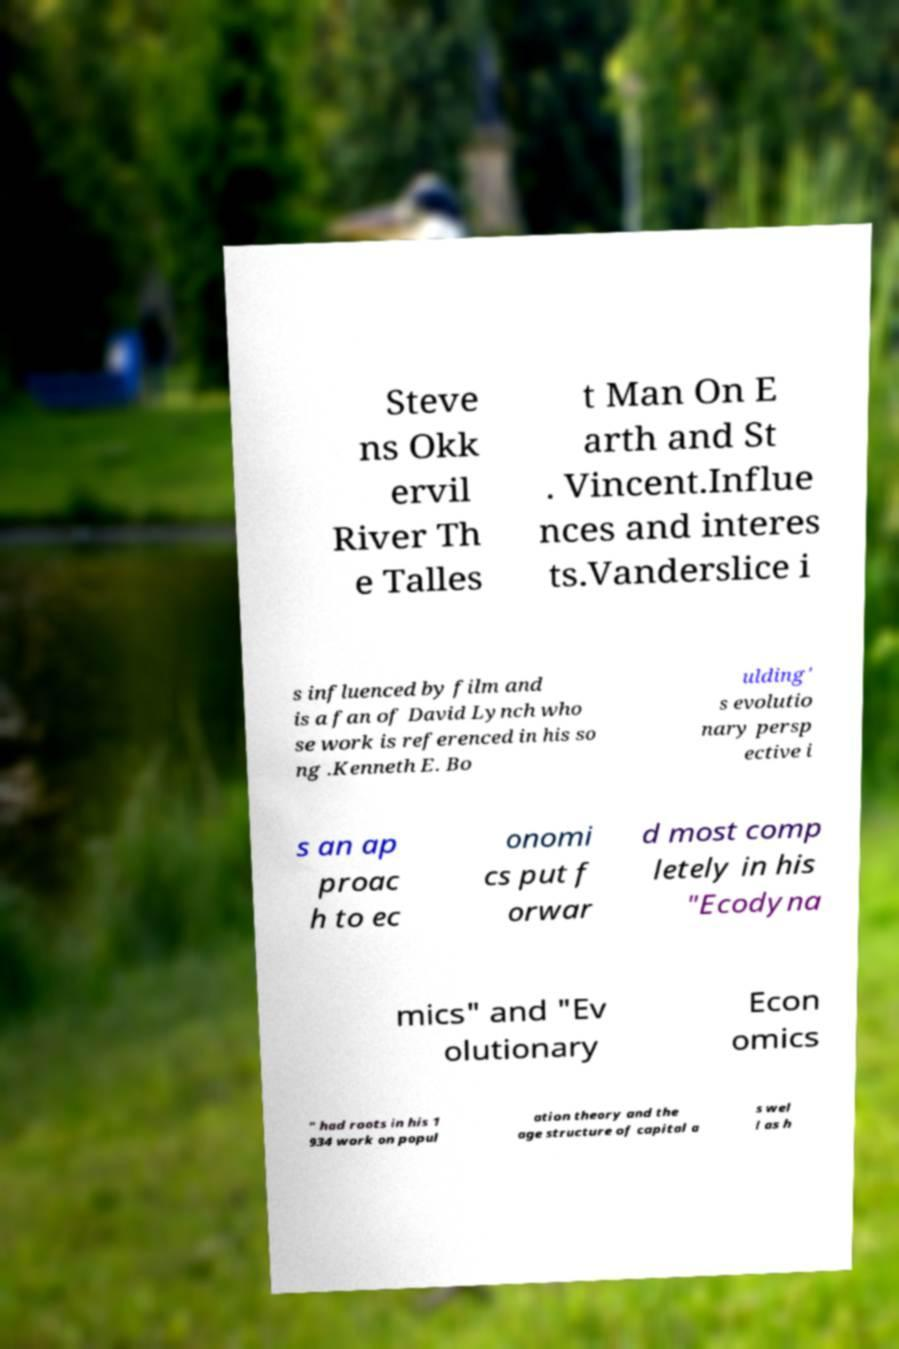Could you assist in decoding the text presented in this image and type it out clearly? Steve ns Okk ervil River Th e Talles t Man On E arth and St . Vincent.Influe nces and interes ts.Vanderslice i s influenced by film and is a fan of David Lynch who se work is referenced in his so ng .Kenneth E. Bo ulding' s evolutio nary persp ective i s an ap proac h to ec onomi cs put f orwar d most comp letely in his "Ecodyna mics" and "Ev olutionary Econ omics " had roots in his 1 934 work on popul ation theory and the age structure of capital a s wel l as h 